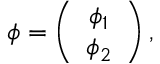Convert formula to latex. <formula><loc_0><loc_0><loc_500><loc_500>\phi = \left ( \begin{array} { c } { { \phi _ { 1 } } } \\ { { \phi _ { 2 } } } \end{array} \right ) ,</formula> 